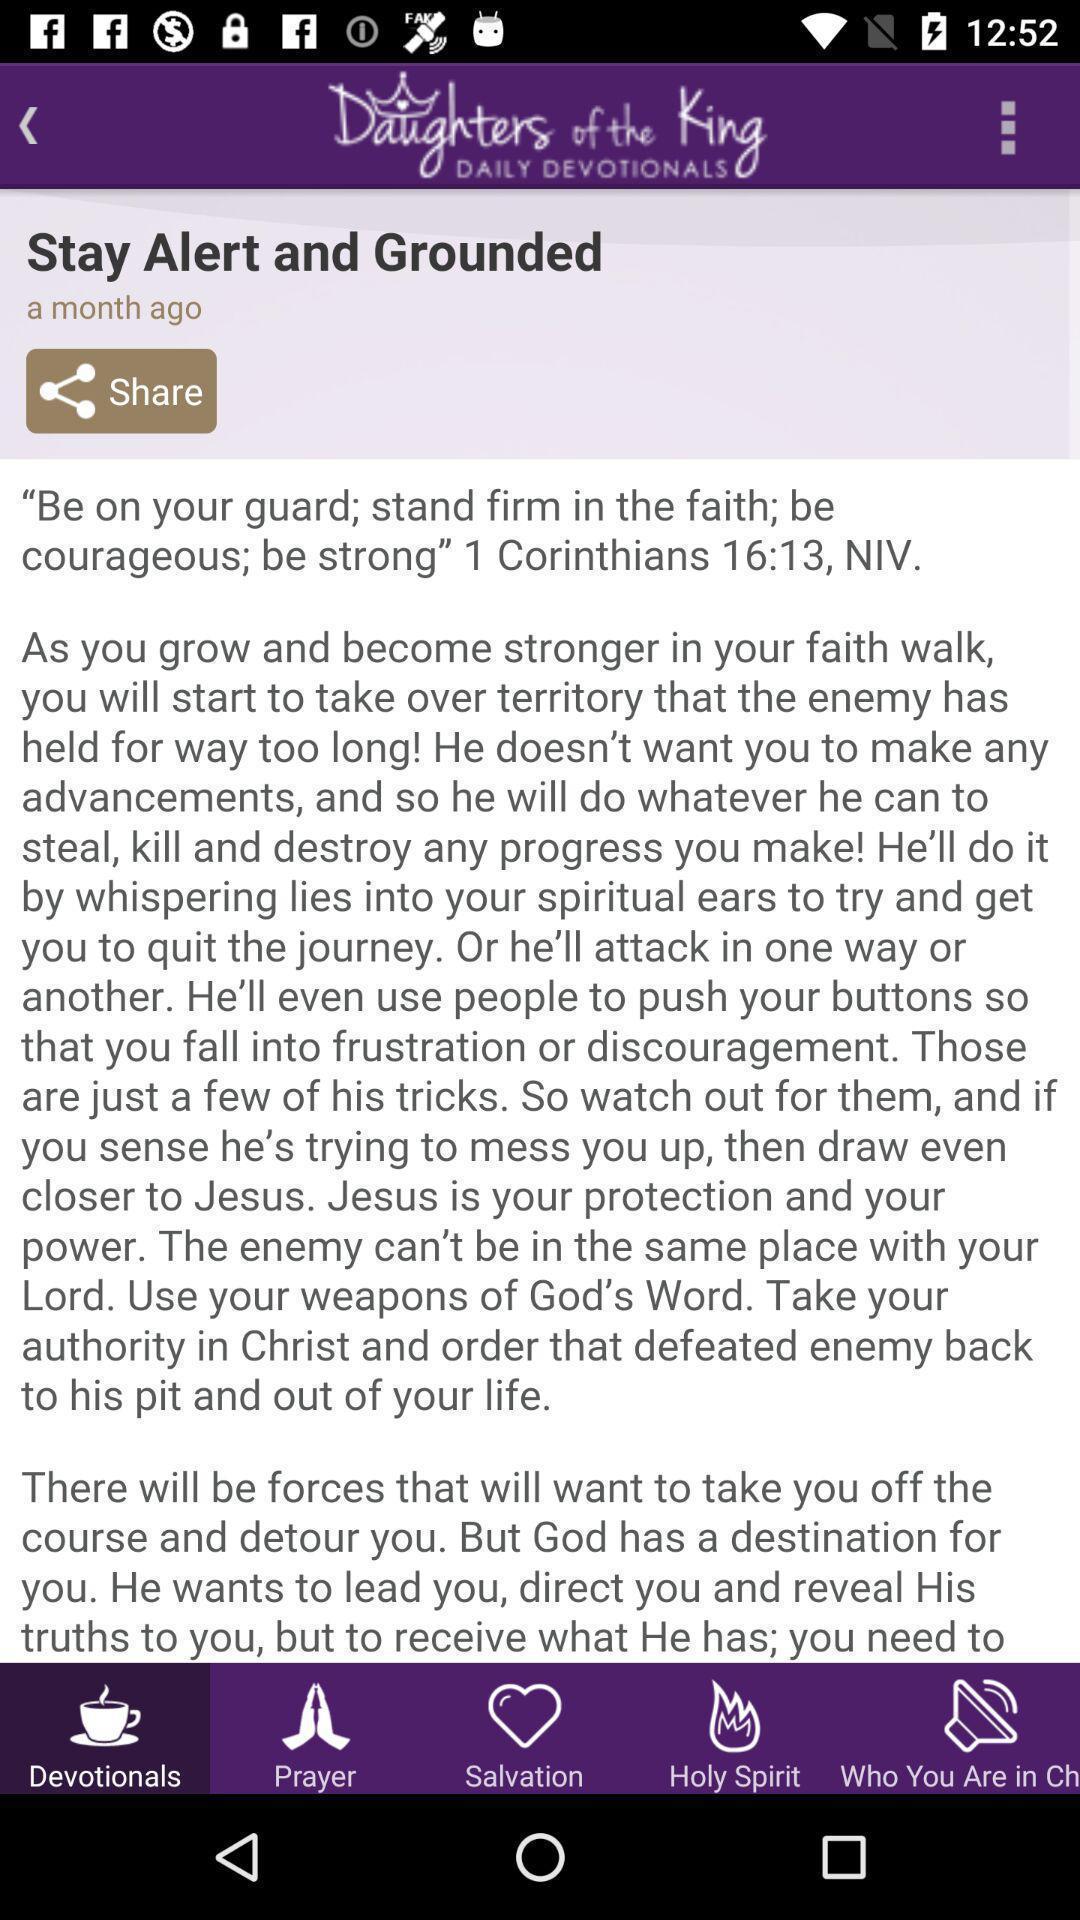Summarize the main components in this picture. Page displaying information in devotional prayer app. 